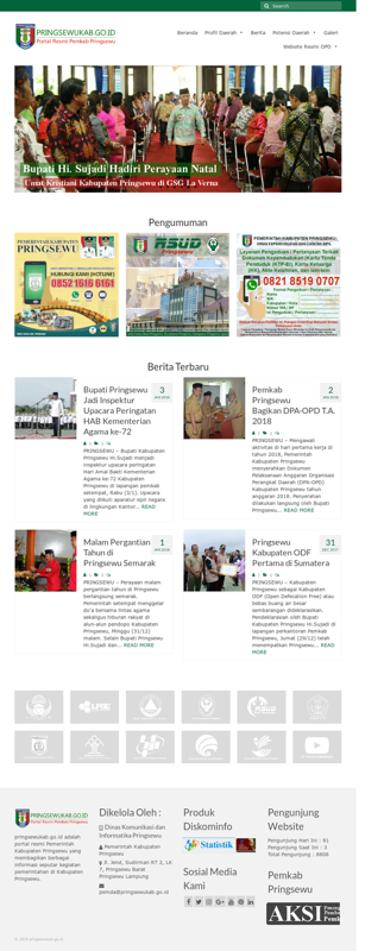What kind of services does the website offer to the public? The website offers a range of services and information to the public, such as recent news, governmental announcements, and contact information. It also appears to have links to various public services and resources, proving to be a comprehensive portal for residents and interested parties. 